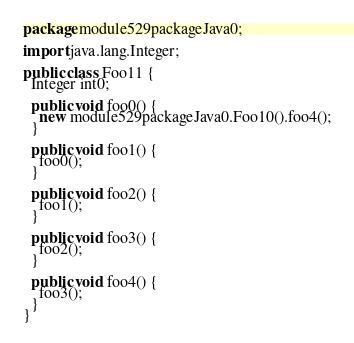<code> <loc_0><loc_0><loc_500><loc_500><_Java_>package module529packageJava0;

import java.lang.Integer;

public class Foo11 {
  Integer int0;

  public void foo0() {
    new module529packageJava0.Foo10().foo4();
  }

  public void foo1() {
    foo0();
  }

  public void foo2() {
    foo1();
  }

  public void foo3() {
    foo2();
  }

  public void foo4() {
    foo3();
  }
}
</code> 